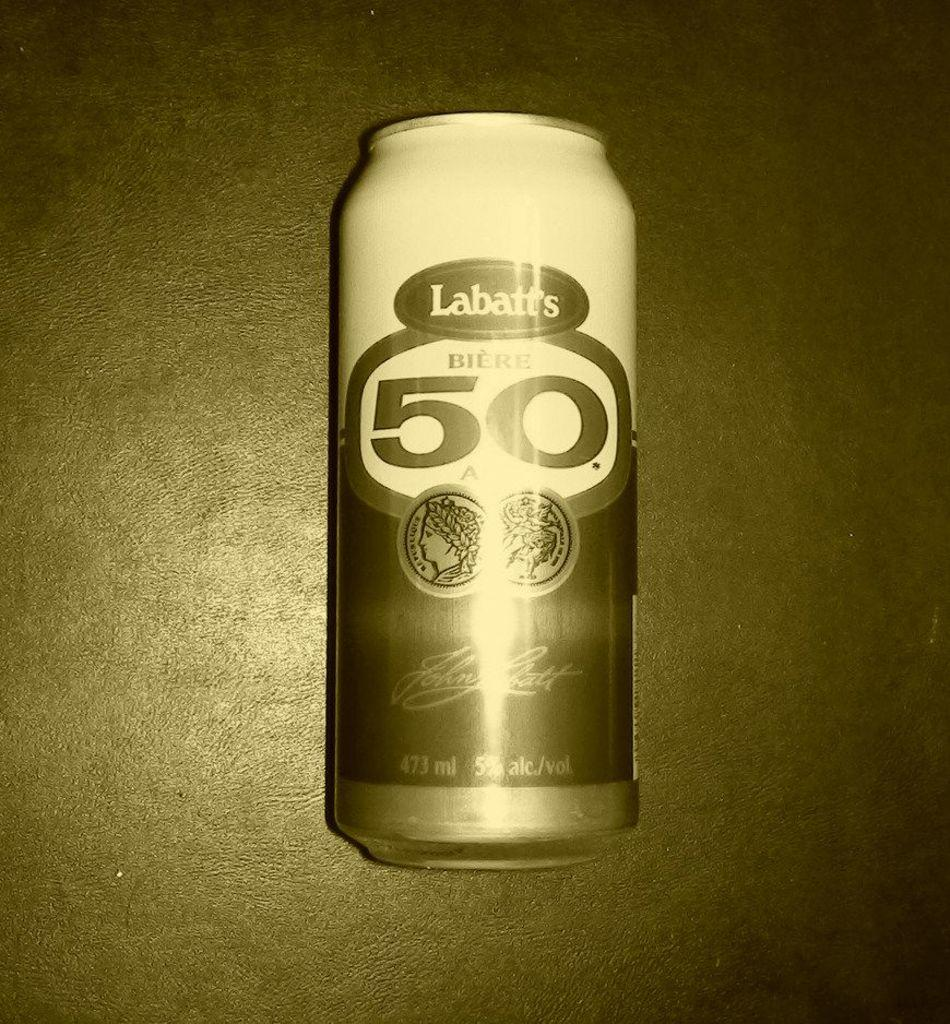<image>
Provide a brief description of the given image. Labatt's beer can at 473ml with a large number 50 on the front. 